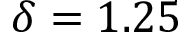<formula> <loc_0><loc_0><loc_500><loc_500>\delta = 1 . 2 5</formula> 